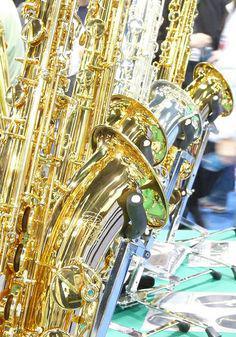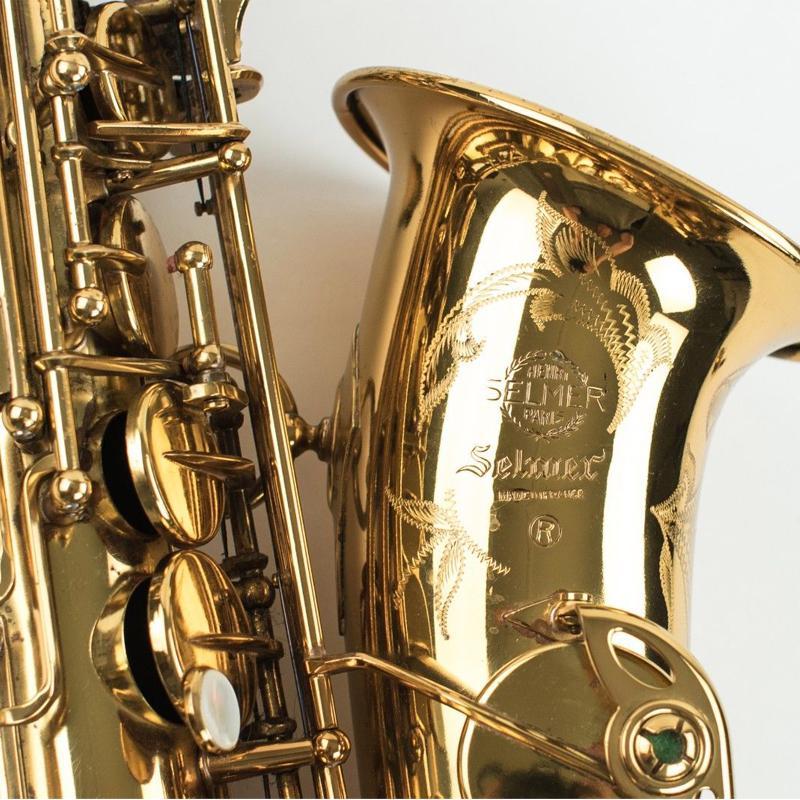The first image is the image on the left, the second image is the image on the right. Analyze the images presented: Is the assertion "There are more instruments in the image on the right." valid? Answer yes or no. No. The first image is the image on the left, the second image is the image on the right. Evaluate the accuracy of this statement regarding the images: "An image shows one saxophone with its mouthpiece separate on the display.". Is it true? Answer yes or no. No. 